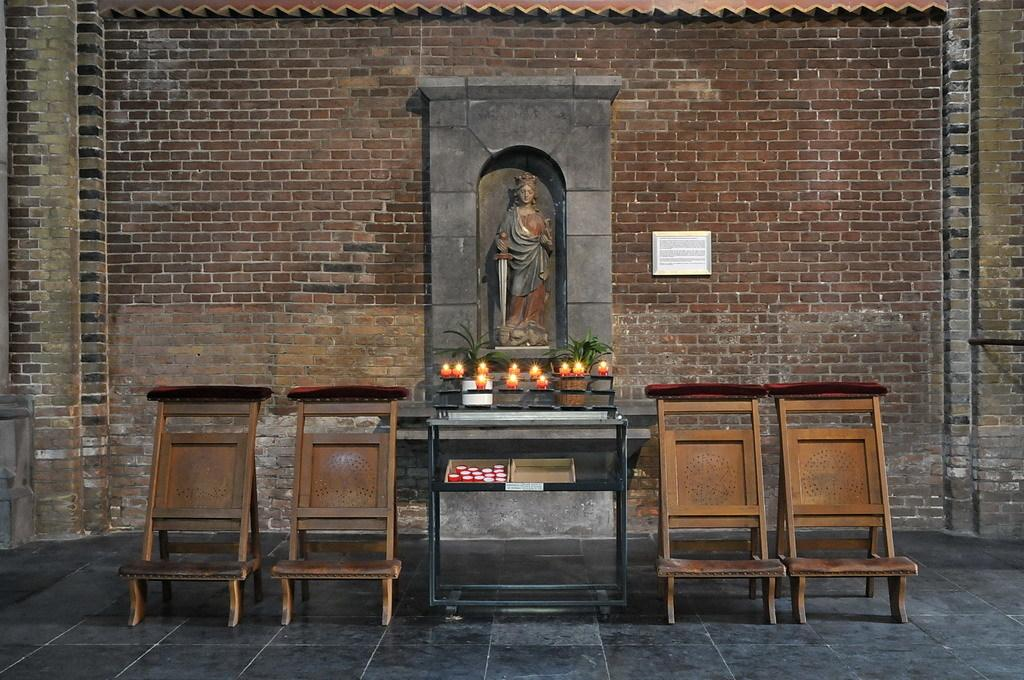What is the main subject in the image? There is a statue present in the image. What is placed before the statue? There are candles placed before the statue. Are all the candles lit in the image? No, there are unlit candles in the image. What type of furniture can be seen in the image? Chairs are visible in the image. What is visible in the background of the image? There is a wall in the background of the image. What type of fruit is placed on the statue in the image? There is no fruit present on the statue in the image. How many cherries can be seen on the chairs in the image? There are no cherries visible in the image; only candles, chairs, and a statue are present. 